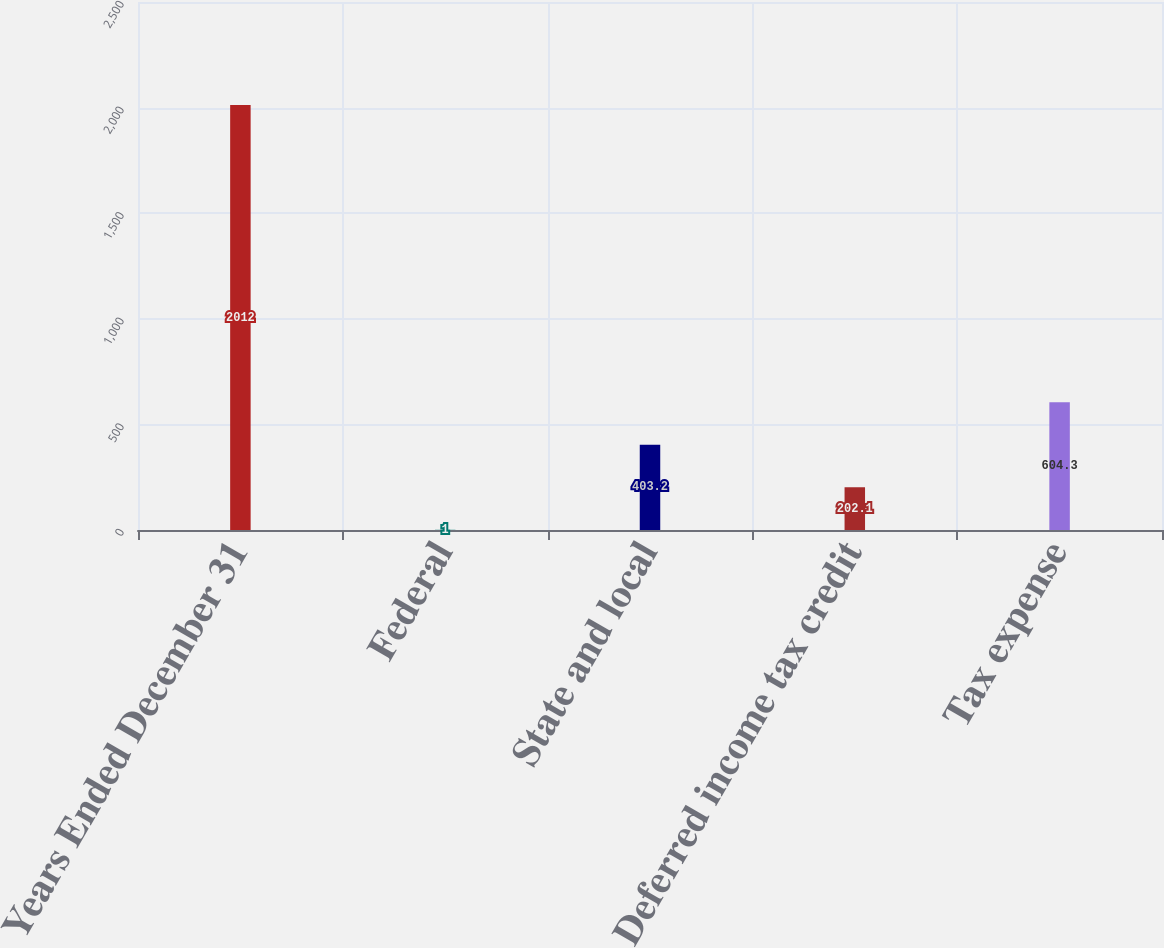Convert chart. <chart><loc_0><loc_0><loc_500><loc_500><bar_chart><fcel>Years Ended December 31<fcel>Federal<fcel>State and local<fcel>Deferred income tax credit<fcel>Tax expense<nl><fcel>2012<fcel>1<fcel>403.2<fcel>202.1<fcel>604.3<nl></chart> 